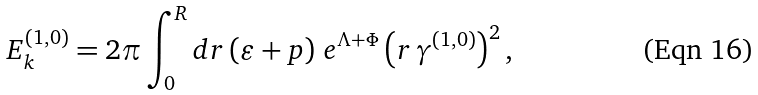<formula> <loc_0><loc_0><loc_500><loc_500>E _ { k } ^ { ( 1 , 0 ) } = 2 \pi \int _ { 0 } ^ { R } d r \left ( \varepsilon + p \right ) \, e ^ { \Lambda + \Phi } \left ( r \, \gamma ^ { ( 1 , 0 ) } \right ) ^ { 2 } ,</formula> 